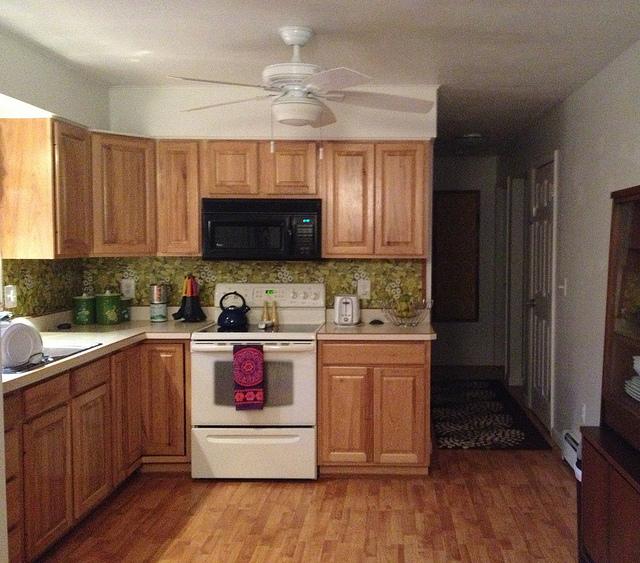Are the microwave and oven matching?
Give a very brief answer. No. What room is this?
Give a very brief answer. Kitchen. How many cabinets are directly above the microwave?
Keep it brief. 2. What is the color of the stove?
Keep it brief. White. Is this kitchen using too much wood?
Answer briefly. Yes. 